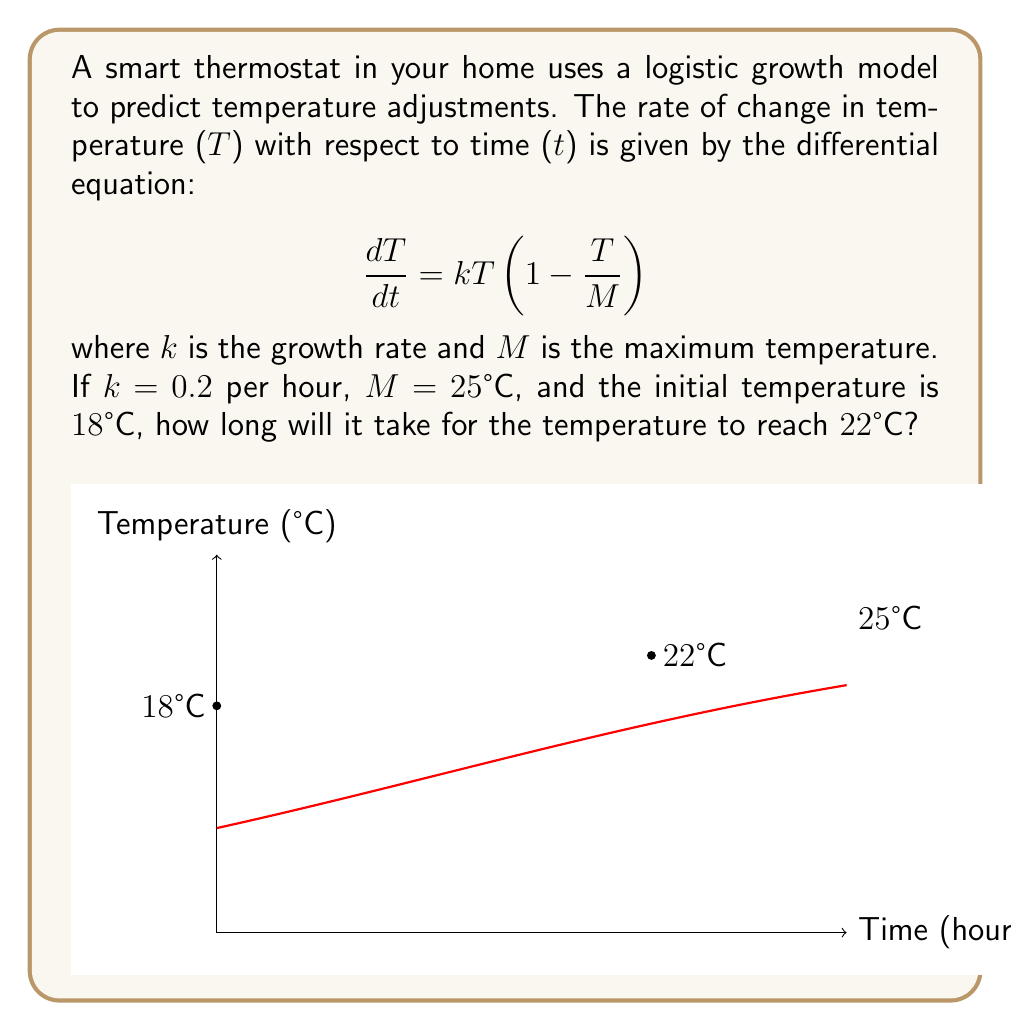Give your solution to this math problem. To solve this problem, we'll follow these steps:

1) The logistic growth model has the solution:

   $$T(t) = \frac{M}{1 + Ce^{-kt}}$$

   where C is a constant determined by the initial conditions.

2) Given T(0) = 18°C, we can find C:

   $$18 = \frac{25}{1 + C}$$
   $$C = \frac{25}{18} - 1 = \frac{7}{18}$$

3) Now our equation is:

   $$T(t) = \frac{25}{1 + \frac{7}{18}e^{-0.2t}}$$

4) We want to find t when T(t) = 22°C. Let's substitute this:

   $$22 = \frac{25}{1 + \frac{7}{18}e^{-0.2t}}$$

5) Solving for t:

   $$1 + \frac{7}{18}e^{-0.2t} = \frac{25}{22}$$
   $$\frac{7}{18}e^{-0.2t} = \frac{25}{22} - 1 = \frac{3}{22}$$
   $$e^{-0.2t} = \frac{3}{22} \cdot \frac{18}{7} = \frac{27}{77}$$
   $$-0.2t = \ln(\frac{27}{77})$$
   $$t = -\frac{1}{0.2}\ln(\frac{27}{77}) \approx 27.47$$

Therefore, it will take approximately 27.47 hours for the temperature to reach 22°C.
Answer: 27.47 hours 